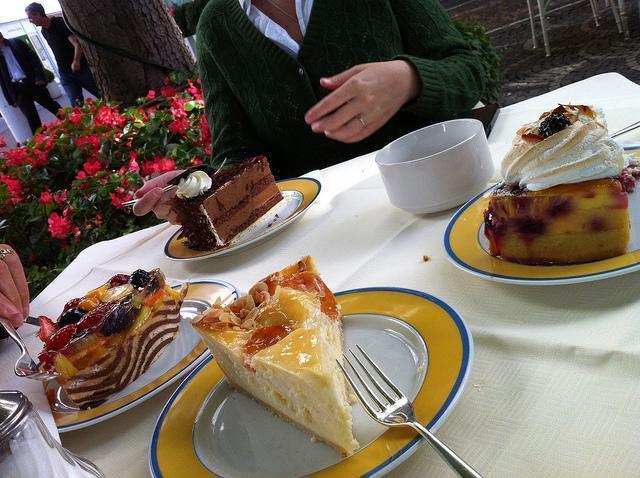How many deserts are shown?
Give a very brief answer. 4. How many plates are on the table?
Give a very brief answer. 4. How many cakes can be seen?
Give a very brief answer. 4. How many people are there?
Give a very brief answer. 4. How many dining tables are in the photo?
Give a very brief answer. 1. How many skiiers are standing to the right of the train car?
Give a very brief answer. 0. 